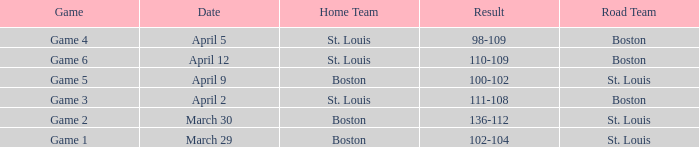What is the Result of Game 3? 111-108. 